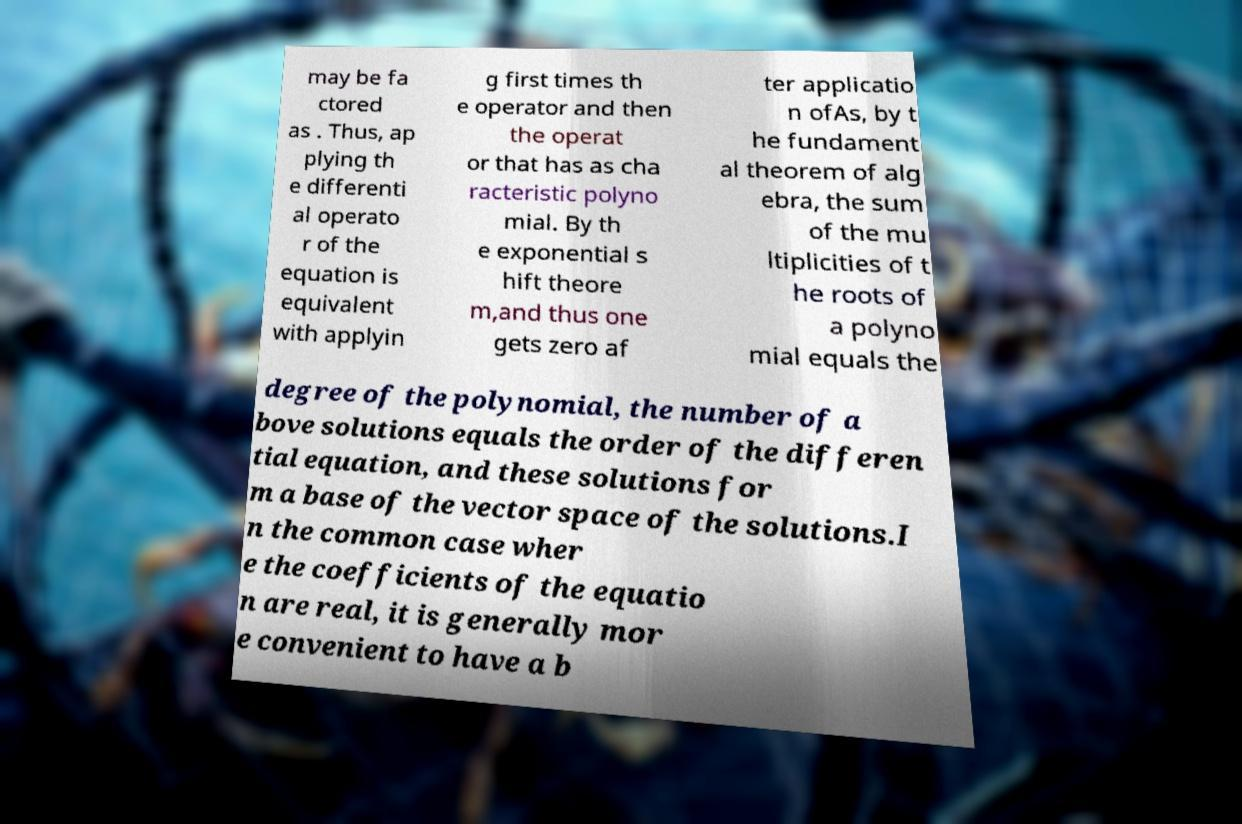Please read and relay the text visible in this image. What does it say? may be fa ctored as . Thus, ap plying th e differenti al operato r of the equation is equivalent with applyin g first times th e operator and then the operat or that has as cha racteristic polyno mial. By th e exponential s hift theore m,and thus one gets zero af ter applicatio n ofAs, by t he fundament al theorem of alg ebra, the sum of the mu ltiplicities of t he roots of a polyno mial equals the degree of the polynomial, the number of a bove solutions equals the order of the differen tial equation, and these solutions for m a base of the vector space of the solutions.I n the common case wher e the coefficients of the equatio n are real, it is generally mor e convenient to have a b 